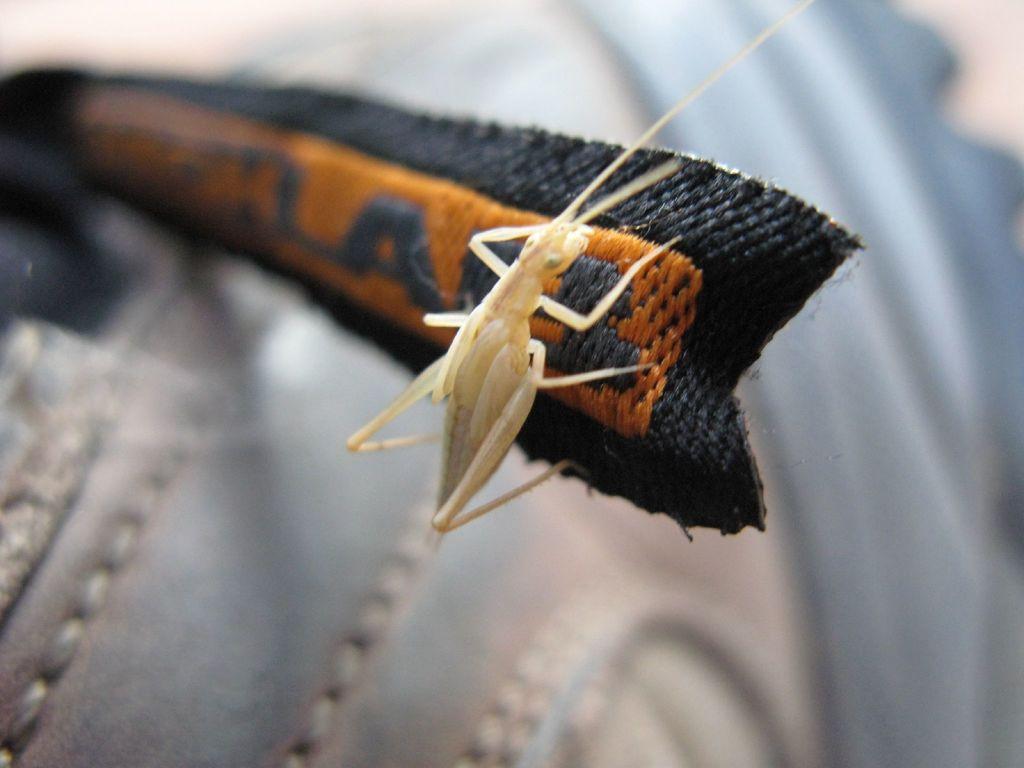Could you give a brief overview of what you see in this image? In the center of the image we can see an object, which is in a black and orange color. On that object, we can see one insect. In the background, we can see it is blurred. 